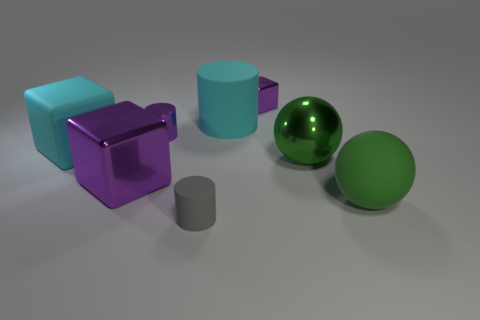What is the shape of the large metallic object that is the same color as the rubber sphere?
Make the answer very short. Sphere. Are there any tiny matte objects that have the same shape as the large purple shiny object?
Offer a terse response. No. Are there fewer large purple shiny blocks that are in front of the gray matte cylinder than big green spheres on the left side of the green matte object?
Your answer should be very brief. Yes. What is the color of the metal sphere?
Ensure brevity in your answer.  Green. Are there any gray rubber objects behind the block that is behind the big cyan block?
Your answer should be compact. No. How many gray objects have the same size as the purple shiny cylinder?
Ensure brevity in your answer.  1. There is a purple shiny cube that is on the left side of the big cyan rubber thing on the right side of the big rubber cube; how many large cyan rubber things are on the left side of it?
Make the answer very short. 1. What number of small things are both to the right of the purple shiny cylinder and behind the big purple shiny cube?
Provide a succinct answer. 1. Is there any other thing that has the same color as the tiny rubber thing?
Offer a very short reply. No. What number of metal things are either large red blocks or cubes?
Your answer should be compact. 2. 